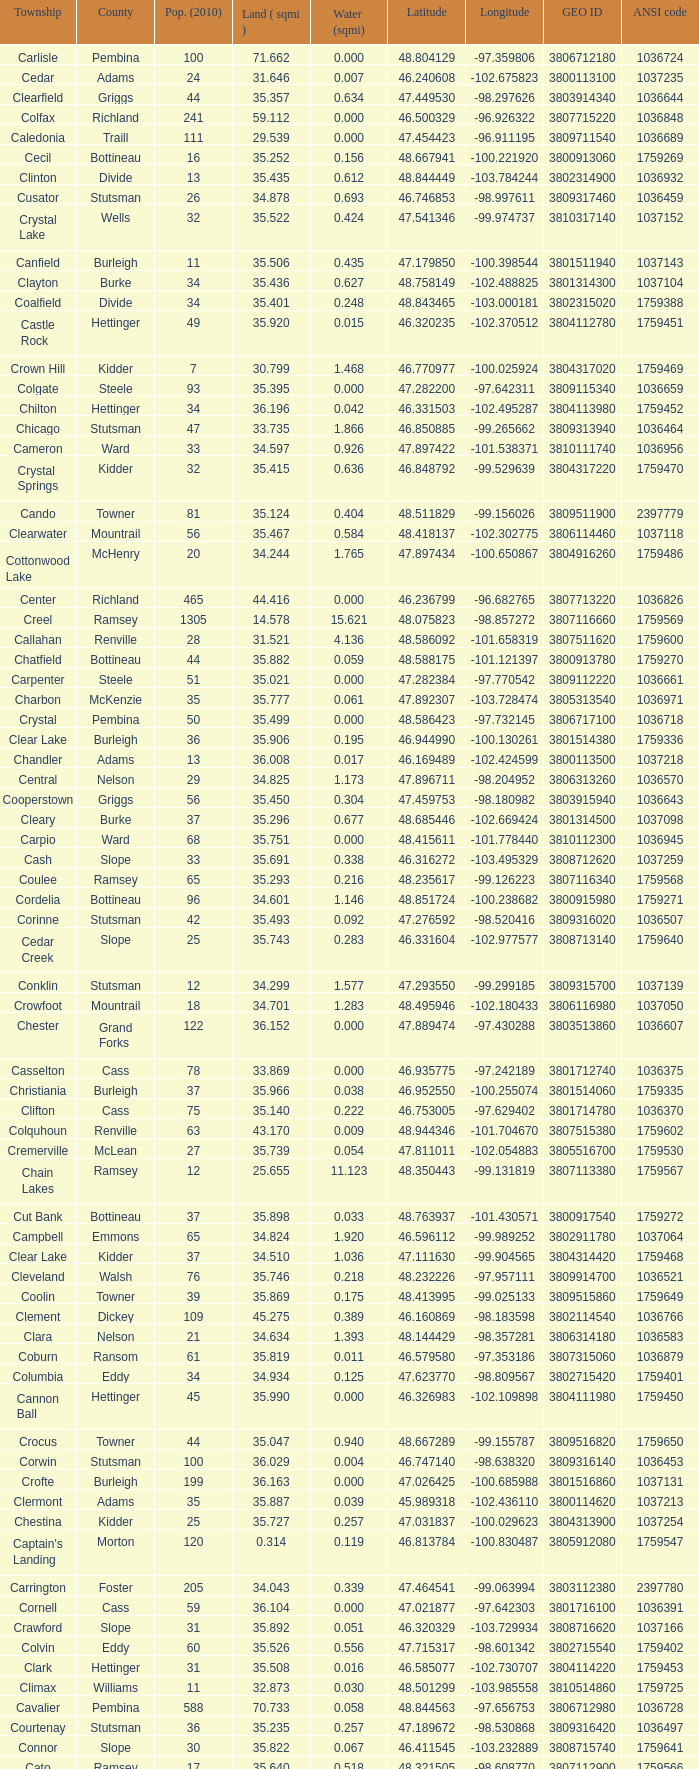What was the county with a latitude of 46.770977? Kidder. Give me the full table as a dictionary. {'header': ['Township', 'County', 'Pop. (2010)', 'Land ( sqmi )', 'Water (sqmi)', 'Latitude', 'Longitude', 'GEO ID', 'ANSI code'], 'rows': [['Carlisle', 'Pembina', '100', '71.662', '0.000', '48.804129', '-97.359806', '3806712180', '1036724'], ['Cedar', 'Adams', '24', '31.646', '0.007', '46.240608', '-102.675823', '3800113100', '1037235'], ['Clearfield', 'Griggs', '44', '35.357', '0.634', '47.449530', '-98.297626', '3803914340', '1036644'], ['Colfax', 'Richland', '241', '59.112', '0.000', '46.500329', '-96.926322', '3807715220', '1036848'], ['Caledonia', 'Traill', '111', '29.539', '0.000', '47.454423', '-96.911195', '3809711540', '1036689'], ['Cecil', 'Bottineau', '16', '35.252', '0.156', '48.667941', '-100.221920', '3800913060', '1759269'], ['Clinton', 'Divide', '13', '35.435', '0.612', '48.844449', '-103.784244', '3802314900', '1036932'], ['Cusator', 'Stutsman', '26', '34.878', '0.693', '46.746853', '-98.997611', '3809317460', '1036459'], ['Crystal Lake', 'Wells', '32', '35.522', '0.424', '47.541346', '-99.974737', '3810317140', '1037152'], ['Canfield', 'Burleigh', '11', '35.506', '0.435', '47.179850', '-100.398544', '3801511940', '1037143'], ['Clayton', 'Burke', '34', '35.436', '0.627', '48.758149', '-102.488825', '3801314300', '1037104'], ['Coalfield', 'Divide', '34', '35.401', '0.248', '48.843465', '-103.000181', '3802315020', '1759388'], ['Castle Rock', 'Hettinger', '49', '35.920', '0.015', '46.320235', '-102.370512', '3804112780', '1759451'], ['Crown Hill', 'Kidder', '7', '30.799', '1.468', '46.770977', '-100.025924', '3804317020', '1759469'], ['Colgate', 'Steele', '93', '35.395', '0.000', '47.282200', '-97.642311', '3809115340', '1036659'], ['Chilton', 'Hettinger', '34', '36.196', '0.042', '46.331503', '-102.495287', '3804113980', '1759452'], ['Chicago', 'Stutsman', '47', '33.735', '1.866', '46.850885', '-99.265662', '3809313940', '1036464'], ['Cameron', 'Ward', '33', '34.597', '0.926', '47.897422', '-101.538371', '3810111740', '1036956'], ['Crystal Springs', 'Kidder', '32', '35.415', '0.636', '46.848792', '-99.529639', '3804317220', '1759470'], ['Cando', 'Towner', '81', '35.124', '0.404', '48.511829', '-99.156026', '3809511900', '2397779'], ['Clearwater', 'Mountrail', '56', '35.467', '0.584', '48.418137', '-102.302775', '3806114460', '1037118'], ['Cottonwood Lake', 'McHenry', '20', '34.244', '1.765', '47.897434', '-100.650867', '3804916260', '1759486'], ['Center', 'Richland', '465', '44.416', '0.000', '46.236799', '-96.682765', '3807713220', '1036826'], ['Creel', 'Ramsey', '1305', '14.578', '15.621', '48.075823', '-98.857272', '3807116660', '1759569'], ['Callahan', 'Renville', '28', '31.521', '4.136', '48.586092', '-101.658319', '3807511620', '1759600'], ['Chatfield', 'Bottineau', '44', '35.882', '0.059', '48.588175', '-101.121397', '3800913780', '1759270'], ['Carpenter', 'Steele', '51', '35.021', '0.000', '47.282384', '-97.770542', '3809112220', '1036661'], ['Charbon', 'McKenzie', '35', '35.777', '0.061', '47.892307', '-103.728474', '3805313540', '1036971'], ['Crystal', 'Pembina', '50', '35.499', '0.000', '48.586423', '-97.732145', '3806717100', '1036718'], ['Clear Lake', 'Burleigh', '36', '35.906', '0.195', '46.944990', '-100.130261', '3801514380', '1759336'], ['Chandler', 'Adams', '13', '36.008', '0.017', '46.169489', '-102.424599', '3800113500', '1037218'], ['Central', 'Nelson', '29', '34.825', '1.173', '47.896711', '-98.204952', '3806313260', '1036570'], ['Cooperstown', 'Griggs', '56', '35.450', '0.304', '47.459753', '-98.180982', '3803915940', '1036643'], ['Cleary', 'Burke', '37', '35.296', '0.677', '48.685446', '-102.669424', '3801314500', '1037098'], ['Carpio', 'Ward', '68', '35.751', '0.000', '48.415611', '-101.778440', '3810112300', '1036945'], ['Cash', 'Slope', '33', '35.691', '0.338', '46.316272', '-103.495329', '3808712620', '1037259'], ['Coulee', 'Ramsey', '65', '35.293', '0.216', '48.235617', '-99.126223', '3807116340', '1759568'], ['Cordelia', 'Bottineau', '96', '34.601', '1.146', '48.851724', '-100.238682', '3800915980', '1759271'], ['Corinne', 'Stutsman', '42', '35.493', '0.092', '47.276592', '-98.520416', '3809316020', '1036507'], ['Cedar Creek', 'Slope', '25', '35.743', '0.283', '46.331604', '-102.977577', '3808713140', '1759640'], ['Conklin', 'Stutsman', '12', '34.299', '1.577', '47.293550', '-99.299185', '3809315700', '1037139'], ['Crowfoot', 'Mountrail', '18', '34.701', '1.283', '48.495946', '-102.180433', '3806116980', '1037050'], ['Chester', 'Grand Forks', '122', '36.152', '0.000', '47.889474', '-97.430288', '3803513860', '1036607'], ['Casselton', 'Cass', '78', '33.869', '0.000', '46.935775', '-97.242189', '3801712740', '1036375'], ['Christiania', 'Burleigh', '37', '35.966', '0.038', '46.952550', '-100.255074', '3801514060', '1759335'], ['Clifton', 'Cass', '75', '35.140', '0.222', '46.753005', '-97.629402', '3801714780', '1036370'], ['Colquhoun', 'Renville', '63', '43.170', '0.009', '48.944346', '-101.704670', '3807515380', '1759602'], ['Cremerville', 'McLean', '27', '35.739', '0.054', '47.811011', '-102.054883', '3805516700', '1759530'], ['Chain Lakes', 'Ramsey', '12', '25.655', '11.123', '48.350443', '-99.131819', '3807113380', '1759567'], ['Cut Bank', 'Bottineau', '37', '35.898', '0.033', '48.763937', '-101.430571', '3800917540', '1759272'], ['Campbell', 'Emmons', '65', '34.824', '1.920', '46.596112', '-99.989252', '3802911780', '1037064'], ['Clear Lake', 'Kidder', '37', '34.510', '1.036', '47.111630', '-99.904565', '3804314420', '1759468'], ['Cleveland', 'Walsh', '76', '35.746', '0.218', '48.232226', '-97.957111', '3809914700', '1036521'], ['Coolin', 'Towner', '39', '35.869', '0.175', '48.413995', '-99.025133', '3809515860', '1759649'], ['Clement', 'Dickey', '109', '45.275', '0.389', '46.160869', '-98.183598', '3802114540', '1036766'], ['Clara', 'Nelson', '21', '34.634', '1.393', '48.144429', '-98.357281', '3806314180', '1036583'], ['Coburn', 'Ransom', '61', '35.819', '0.011', '46.579580', '-97.353186', '3807315060', '1036879'], ['Columbia', 'Eddy', '34', '34.934', '0.125', '47.623770', '-98.809567', '3802715420', '1759401'], ['Cannon Ball', 'Hettinger', '45', '35.990', '0.000', '46.326983', '-102.109898', '3804111980', '1759450'], ['Crocus', 'Towner', '44', '35.047', '0.940', '48.667289', '-99.155787', '3809516820', '1759650'], ['Corwin', 'Stutsman', '100', '36.029', '0.004', '46.747140', '-98.638320', '3809316140', '1036453'], ['Crofte', 'Burleigh', '199', '36.163', '0.000', '47.026425', '-100.685988', '3801516860', '1037131'], ['Clermont', 'Adams', '35', '35.887', '0.039', '45.989318', '-102.436110', '3800114620', '1037213'], ['Chestina', 'Kidder', '25', '35.727', '0.257', '47.031837', '-100.029623', '3804313900', '1037254'], ["Captain's Landing", 'Morton', '120', '0.314', '0.119', '46.813784', '-100.830487', '3805912080', '1759547'], ['Carrington', 'Foster', '205', '34.043', '0.339', '47.464541', '-99.063994', '3803112380', '2397780'], ['Cornell', 'Cass', '59', '36.104', '0.000', '47.021877', '-97.642303', '3801716100', '1036391'], ['Crawford', 'Slope', '31', '35.892', '0.051', '46.320329', '-103.729934', '3808716620', '1037166'], ['Colvin', 'Eddy', '60', '35.526', '0.556', '47.715317', '-98.601342', '3802715540', '1759402'], ['Clark', 'Hettinger', '31', '35.508', '0.016', '46.585077', '-102.730707', '3804114220', '1759453'], ['Climax', 'Williams', '11', '32.873', '0.030', '48.501299', '-103.985558', '3810514860', '1759725'], ['Cavalier', 'Pembina', '588', '70.733', '0.058', '48.844563', '-97.656753', '3806712980', '1036728'], ['Courtenay', 'Stutsman', '36', '35.235', '0.257', '47.189672', '-98.530868', '3809316420', '1036497'], ['Connor', 'Slope', '30', '35.822', '0.067', '46.411545', '-103.232889', '3808715740', '1759641'], ['Cato', 'Ramsey', '17', '35.640', '0.518', '48.321505', '-98.608770', '3807112900', '1759566'], ['Campbell', 'Hettinger', '29', '35.131', '0.021', '46.582196', '-102.350268', '3804111820', '1759449'], ['Cherry Lake', 'Eddy', '33', '33.381', '1.564', '47.643166', '-98.716308', '3802713820', '1759400'], ['Carter', 'Burke', '13', '35.117', '0.802', '48.856110', '-102.340216', '3801312500', '1759317'], ['Chaseley', 'Wells', '38', '35.156', '0.815', '47.464888', '-99.830606', '3810313740', '1037183'], ['Carroll', 'Slope', '10', '35.994', '0.000', '46.411232', '-102.988525', '3808712420', '1759639'], ['Crane Creek', 'Mountrail', '84', '35.704', '0.278', '48.074507', '-102.380242', '3806116540', '1037041'], ['Cathay', 'Wells', '56', '35.645', '0.098', '47.540251', '-99.459981', '3810312860', '2397782'], ['Cromwell', 'Burleigh', '35', '36.208', '0.000', '47.026008', '-100.558805', '3801516900', '1037133'], ['Cuba', 'Barnes', '76', '35.709', '0.032', '46.851144', '-97.860271', '3800317300', '1036409'], ['Colville', 'Burke', '65', '33.259', '1.365', '48.591025', '-102.693028', '3801315500', '1037097'], ['Clay', 'Renville', '39', '35.861', '0.052', '48.678600', '-101.514193', '3807514260', '1759601'], ['Champion', 'Williams', '16', '35.869', '0.120', '48.410210', '-103.222457', '3810513460', '1037032'], ['Cottonwood', 'Mountrail', '32', '33.669', '2.318', '48.427789', '-102.527219', '3806116220', '1037101'], ['Carbondale', 'Ward', '47', '35.507', '0.013', '48.500813', '-101.910874', '3810112100', '1033987'], ['Casey', 'Ransom', '90', '36.293', '0.031', '46.492998', '-97.605198', '3807312580', '1036870']]} 